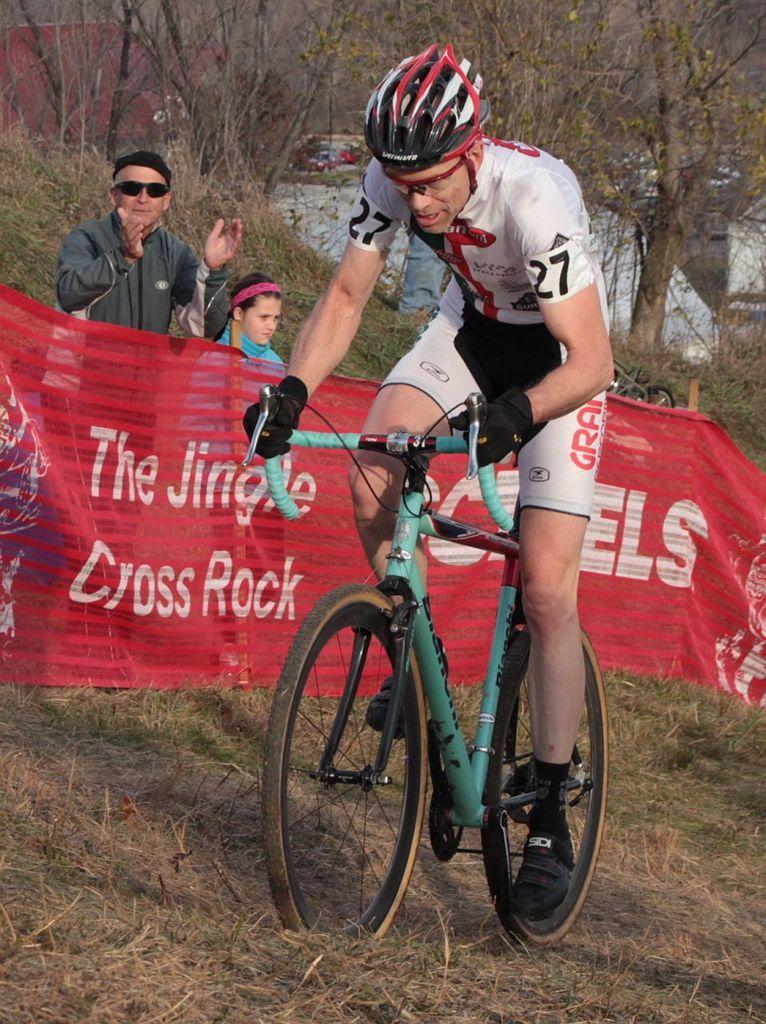Could you give a brief overview of what you see in this image? A person wearing a gloves and helmet and a goggle is riding a cycle on a grass land. In the background there is a banner, trees, a person wearing a goggles and a cap is standing, near to him a girl is also standing. Also there are trees in the background. 